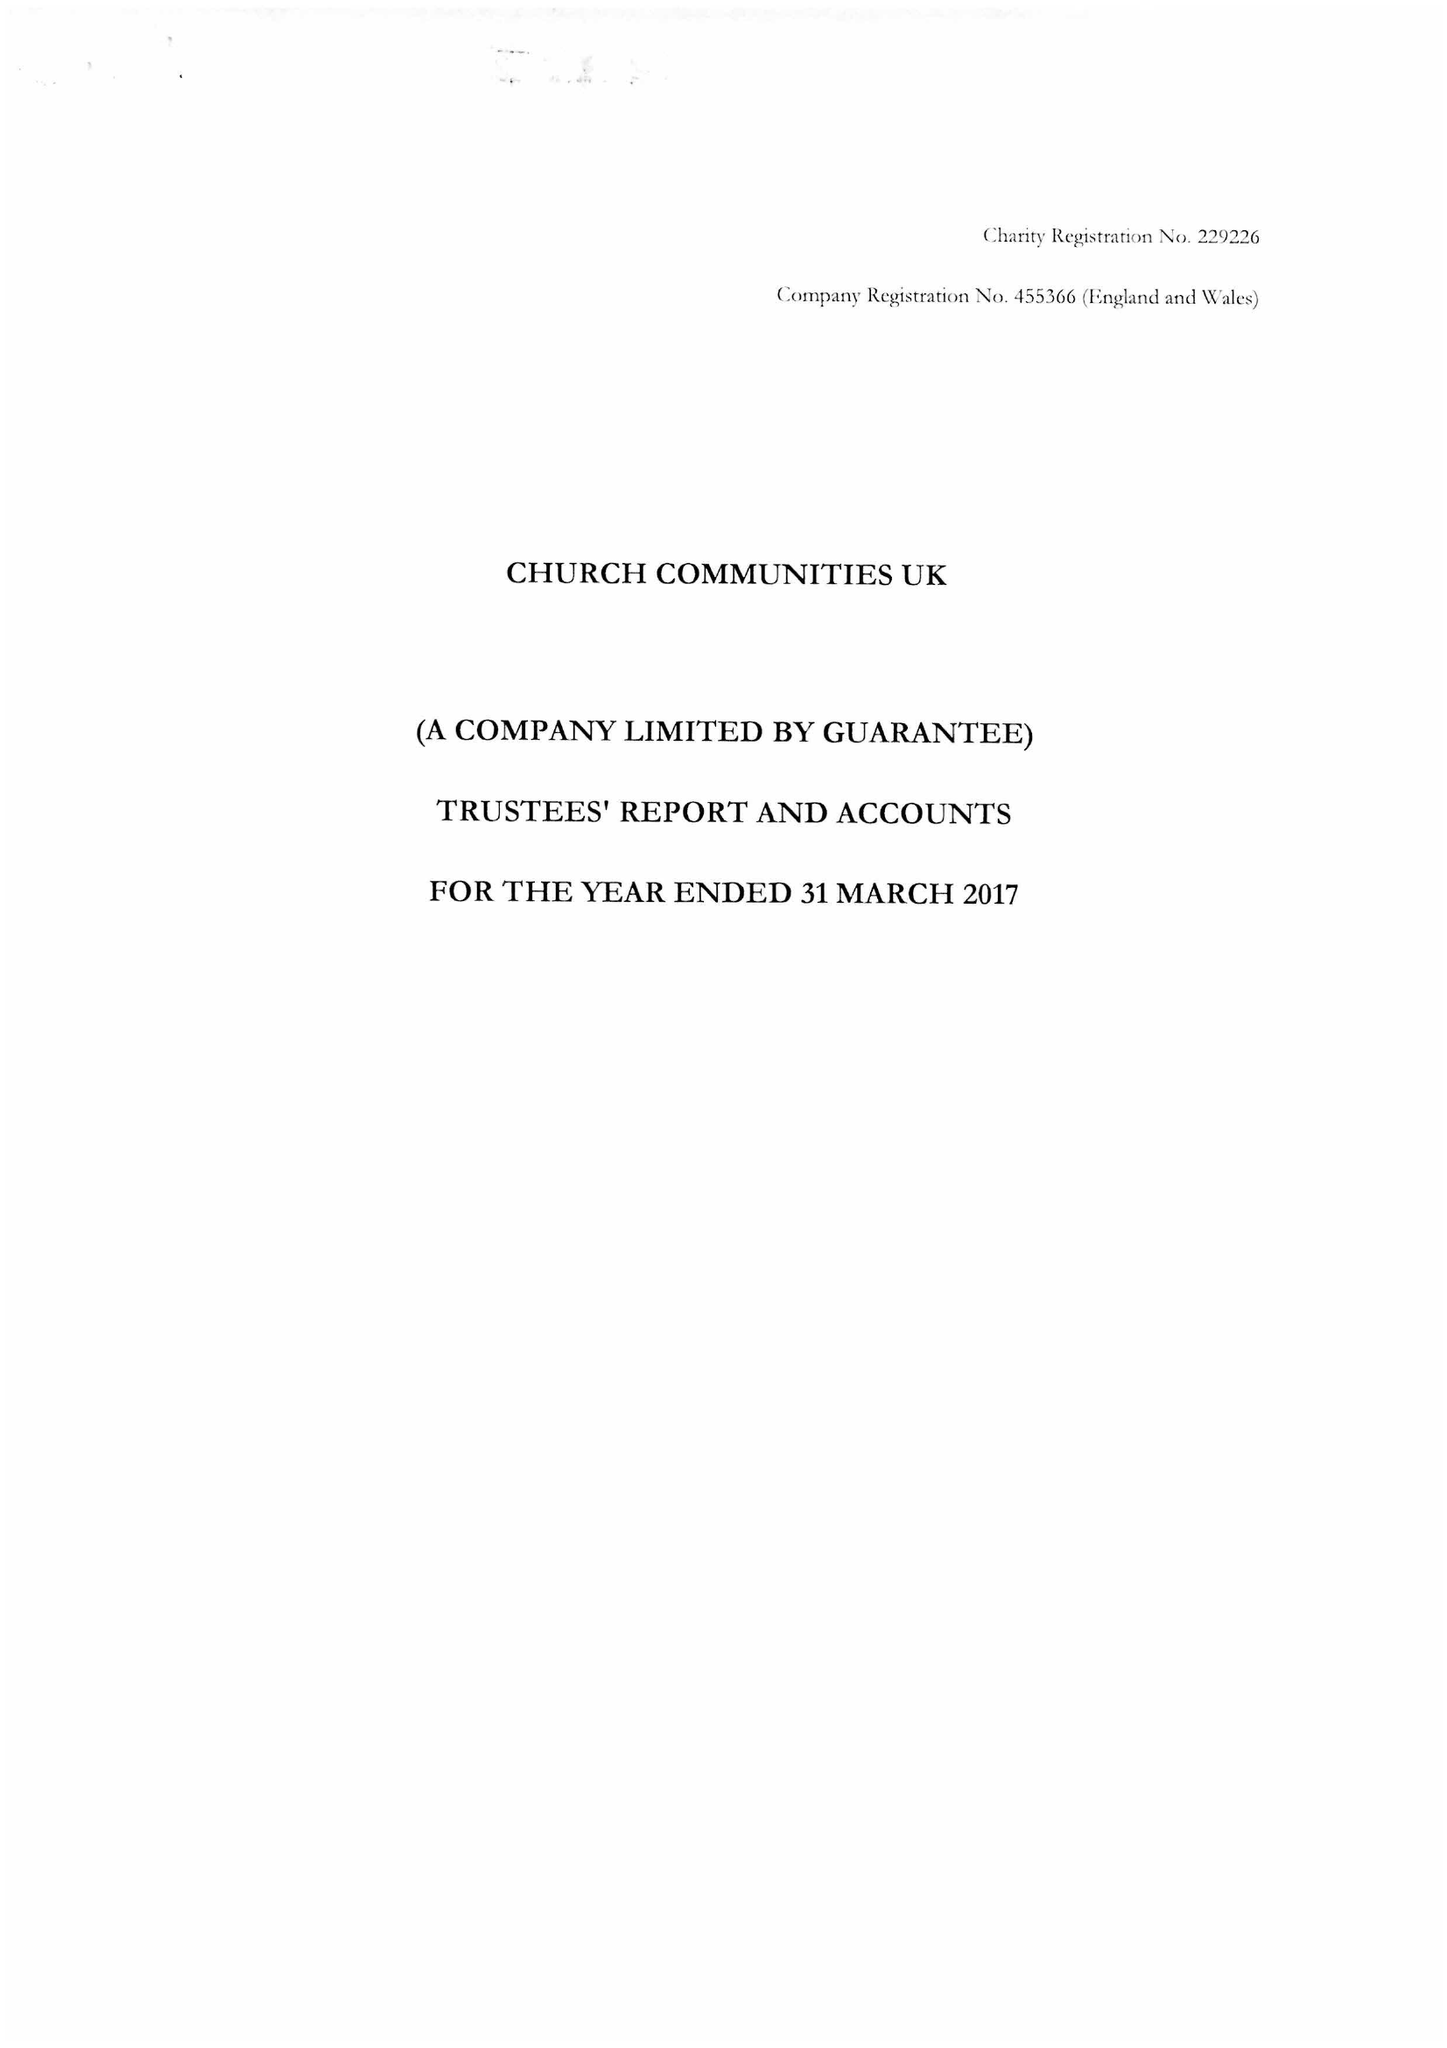What is the value for the charity_number?
Answer the question using a single word or phrase. 229226 